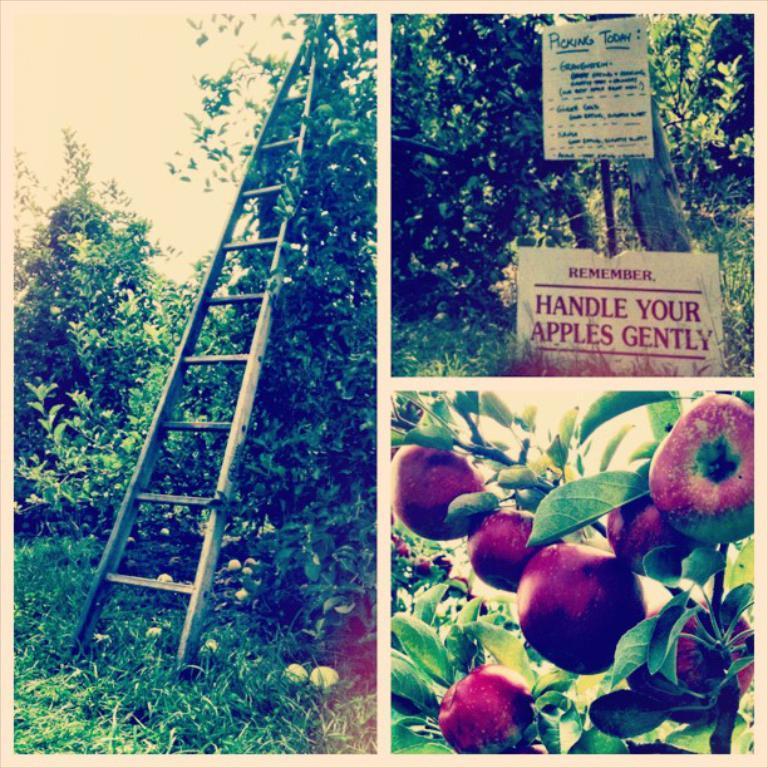In one or two sentences, can you explain what this image depicts? This image is a collage of trees, grass, informational boards, ladder and also fruits. 